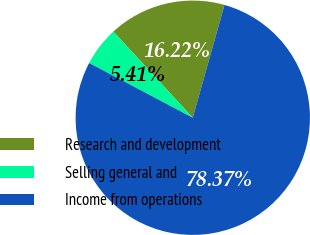Convert chart. <chart><loc_0><loc_0><loc_500><loc_500><pie_chart><fcel>Research and development<fcel>Selling general and<fcel>Income from operations<nl><fcel>16.22%<fcel>5.41%<fcel>78.38%<nl></chart> 